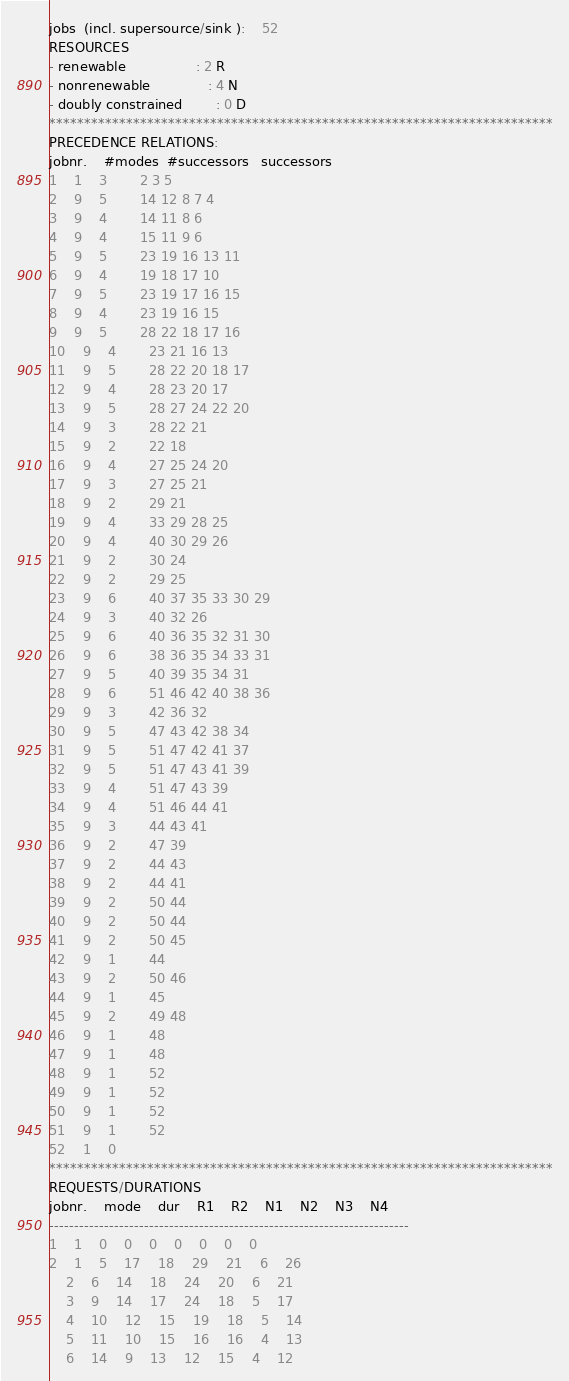Convert code to text. <code><loc_0><loc_0><loc_500><loc_500><_ObjectiveC_>jobs  (incl. supersource/sink ):	52
RESOURCES
- renewable                 : 2 R
- nonrenewable              : 4 N
- doubly constrained        : 0 D
************************************************************************
PRECEDENCE RELATIONS:
jobnr.    #modes  #successors   successors
1	1	3		2 3 5 
2	9	5		14 12 8 7 4 
3	9	4		14 11 8 6 
4	9	4		15 11 9 6 
5	9	5		23 19 16 13 11 
6	9	4		19 18 17 10 
7	9	5		23 19 17 16 15 
8	9	4		23 19 16 15 
9	9	5		28 22 18 17 16 
10	9	4		23 21 16 13 
11	9	5		28 22 20 18 17 
12	9	4		28 23 20 17 
13	9	5		28 27 24 22 20 
14	9	3		28 22 21 
15	9	2		22 18 
16	9	4		27 25 24 20 
17	9	3		27 25 21 
18	9	2		29 21 
19	9	4		33 29 28 25 
20	9	4		40 30 29 26 
21	9	2		30 24 
22	9	2		29 25 
23	9	6		40 37 35 33 30 29 
24	9	3		40 32 26 
25	9	6		40 36 35 32 31 30 
26	9	6		38 36 35 34 33 31 
27	9	5		40 39 35 34 31 
28	9	6		51 46 42 40 38 36 
29	9	3		42 36 32 
30	9	5		47 43 42 38 34 
31	9	5		51 47 42 41 37 
32	9	5		51 47 43 41 39 
33	9	4		51 47 43 39 
34	9	4		51 46 44 41 
35	9	3		44 43 41 
36	9	2		47 39 
37	9	2		44 43 
38	9	2		44 41 
39	9	2		50 44 
40	9	2		50 44 
41	9	2		50 45 
42	9	1		44 
43	9	2		50 46 
44	9	1		45 
45	9	2		49 48 
46	9	1		48 
47	9	1		48 
48	9	1		52 
49	9	1		52 
50	9	1		52 
51	9	1		52 
52	1	0		
************************************************************************
REQUESTS/DURATIONS
jobnr.	mode	dur	R1	R2	N1	N2	N3	N4	
------------------------------------------------------------------------
1	1	0	0	0	0	0	0	0	
2	1	5	17	18	29	21	6	26	
	2	6	14	18	24	20	6	21	
	3	9	14	17	24	18	5	17	
	4	10	12	15	19	18	5	14	
	5	11	10	15	16	16	4	13	
	6	14	9	13	12	15	4	12	</code> 